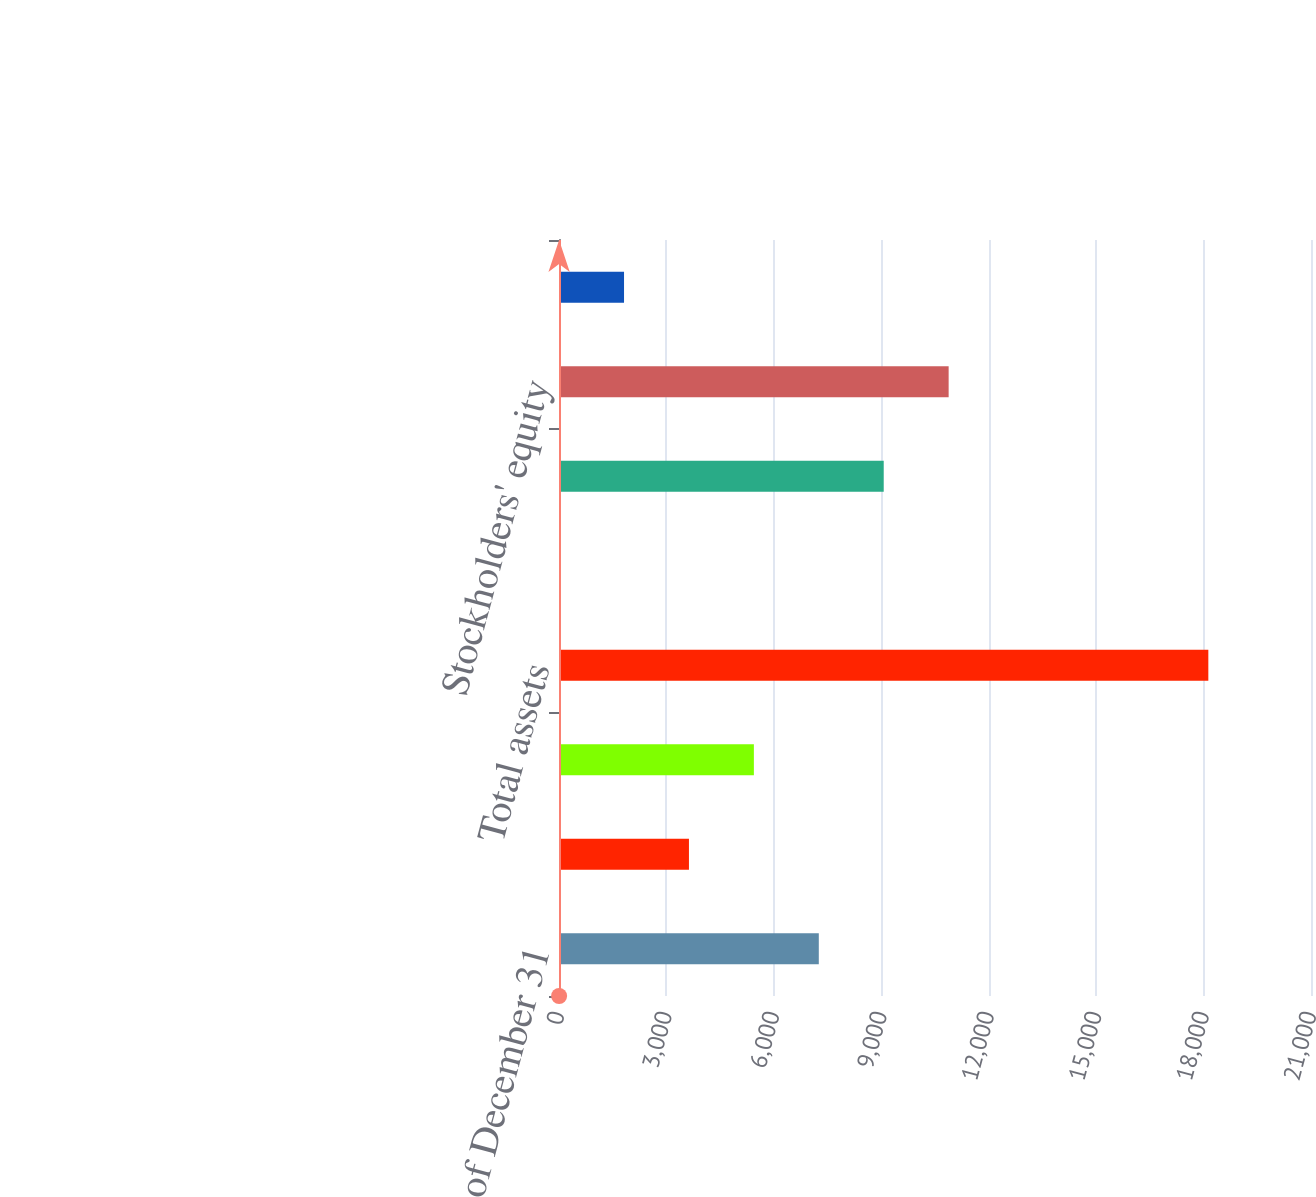Convert chart to OTSL. <chart><loc_0><loc_0><loc_500><loc_500><bar_chart><fcel>As of December 31<fcel>Cash cash equivalents and<fcel>Working capital<fcel>Total assets<fcel>Borrowings (short-term)<fcel>Borrowings (long-term)<fcel>Stockholders' equity<fcel>Book value per common share<nl><fcel>7255<fcel>3629<fcel>5442<fcel>18133<fcel>3<fcel>9068<fcel>10881<fcel>1816<nl></chart> 